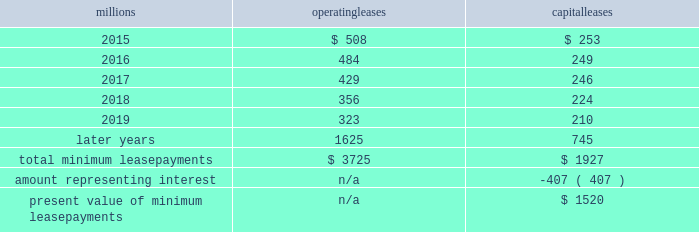Direct the activities of the vies and , therefore , do not control the ongoing activities that have a significant impact on the economic performance of the vies .
Additionally , we do not have the obligation to absorb losses of the vies or the right to receive benefits of the vies that could potentially be significant to the we are not considered to be the primary beneficiary and do not consolidate these vies because our actions and decisions do not have the most significant effect on the vie 2019s performance and our fixed-price purchase options are not considered to be potentially significant to the vies .
The future minimum lease payments associated with the vie leases totaled $ 3.0 billion as of december 31 , 2014 .
17 .
Leases we lease certain locomotives , freight cars , and other property .
The consolidated statements of financial position as of december 31 , 2014 and 2013 included $ 2454 million , net of $ 1210 million of accumulated depreciation , and $ 2486 million , net of $ 1092 million of accumulated depreciation , respectively , for properties held under capital leases .
A charge to income resulting from the depreciation for assets held under capital leases is included within depreciation expense in our consolidated statements of income .
Future minimum lease payments for operating and capital leases with initial or remaining non-cancelable lease terms in excess of one year as of december 31 , 2014 , were as follows : millions operating leases capital leases .
Approximately 95% ( 95 % ) of capital lease payments relate to locomotives .
Rent expense for operating leases with terms exceeding one month was $ 593 million in 2014 , $ 618 million in 2013 , and $ 631 million in 2012 .
When cash rental payments are not made on a straight-line basis , we recognize variable rental expense on a straight-line basis over the lease term .
Contingent rentals and sub-rentals are not significant .
18 .
Commitments and contingencies asserted and unasserted claims 2013 various claims and lawsuits are pending against us and certain of our subsidiaries .
We cannot fully determine the effect of all asserted and unasserted claims on our consolidated results of operations , financial condition , or liquidity ; however , to the extent possible , where asserted and unasserted claims are considered probable and where such claims can be reasonably estimated , we have recorded a liability .
We do not expect that any known lawsuits , claims , environmental costs , commitments , contingent liabilities , or guarantees will have a material adverse effect on our consolidated results of operations , financial condition , or liquidity after taking into account liabilities and insurance recoveries previously recorded for these matters .
Personal injury 2013 the cost of personal injuries to employees and others related to our activities is charged to expense based on estimates of the ultimate cost and number of incidents each year .
We use an actuarial analysis to measure the expense and liability , including unasserted claims .
The federal employers 2019 liability act ( fela ) governs compensation for work-related accidents .
Under fela , damages are assessed based on a finding of fault through litigation or out-of-court settlements .
We offer a comprehensive variety of services and rehabilitation programs for employees who are injured at work .
Our personal injury liability is not discounted to present value due to the uncertainty surrounding the timing of future payments .
Approximately 93% ( 93 % ) of the recorded liability is related to asserted claims and approximately 7% ( 7 % ) is related to unasserted claims at december 31 , 2014 .
Because of the uncertainty .
In december 2014 , what was the percentage of the total future minimum lease payments that was due in 2016? 
Computations: ((484 + 249) / (3725 + 1927))
Answer: 0.12969. 